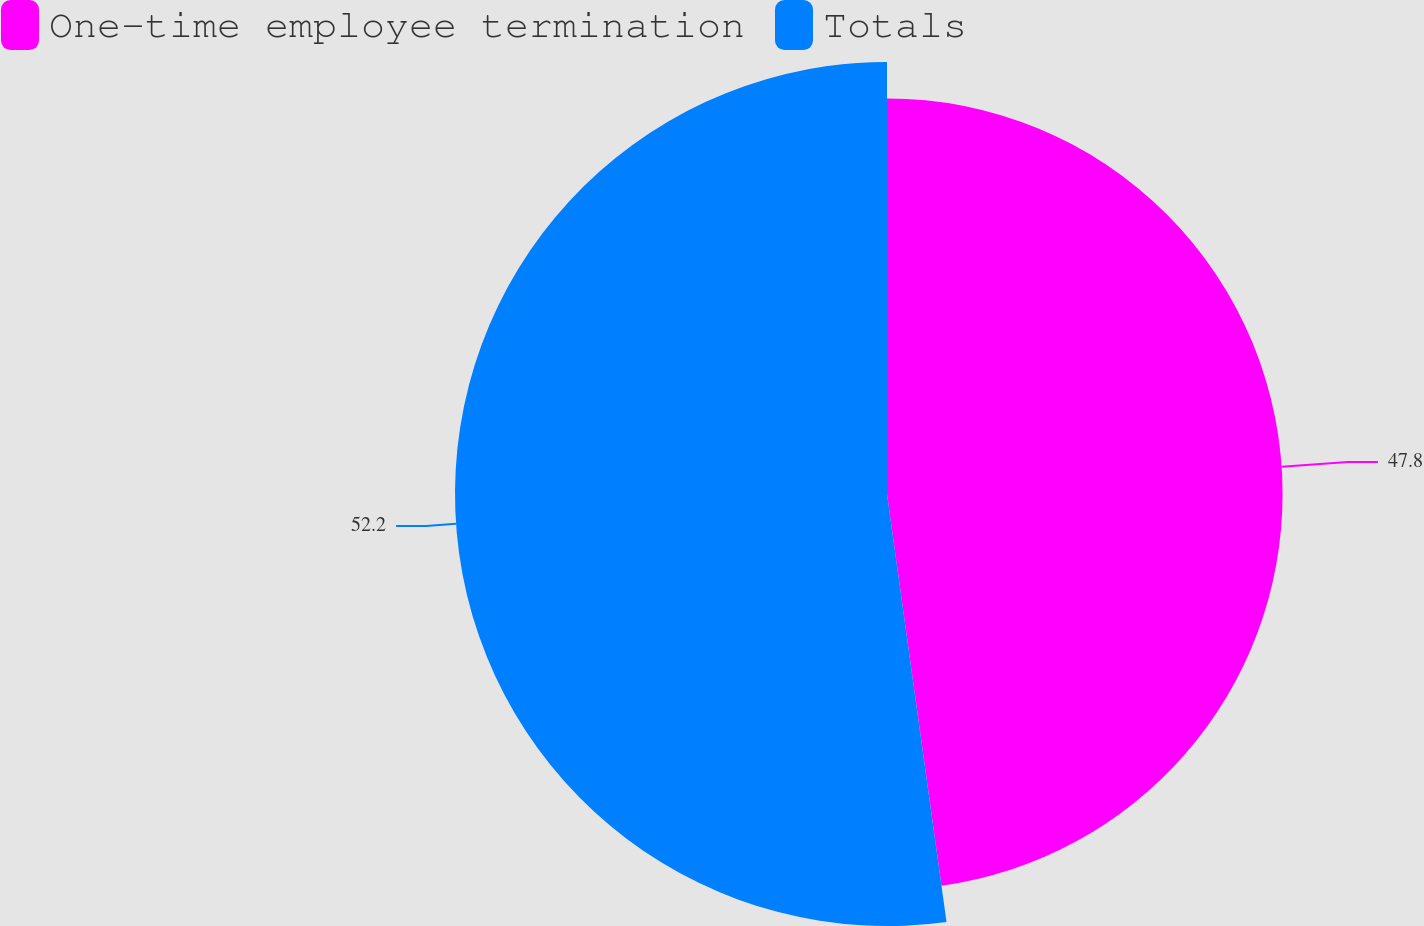<chart> <loc_0><loc_0><loc_500><loc_500><pie_chart><fcel>One-time employee termination<fcel>Totals<nl><fcel>47.8%<fcel>52.2%<nl></chart> 